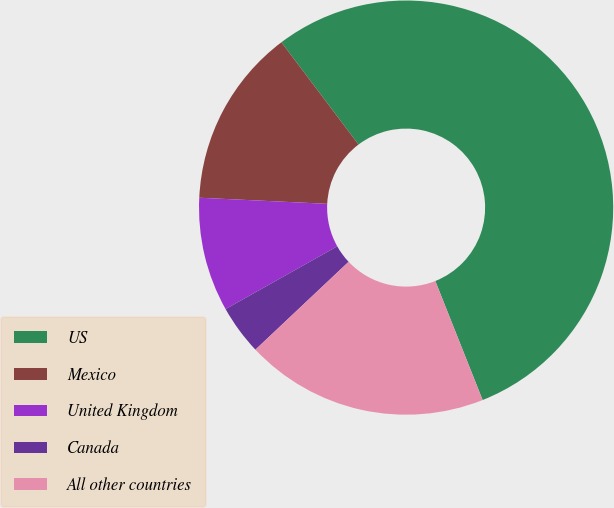Convert chart to OTSL. <chart><loc_0><loc_0><loc_500><loc_500><pie_chart><fcel>US<fcel>Mexico<fcel>United Kingdom<fcel>Canada<fcel>All other countries<nl><fcel>54.26%<fcel>13.95%<fcel>8.91%<fcel>3.88%<fcel>18.99%<nl></chart> 